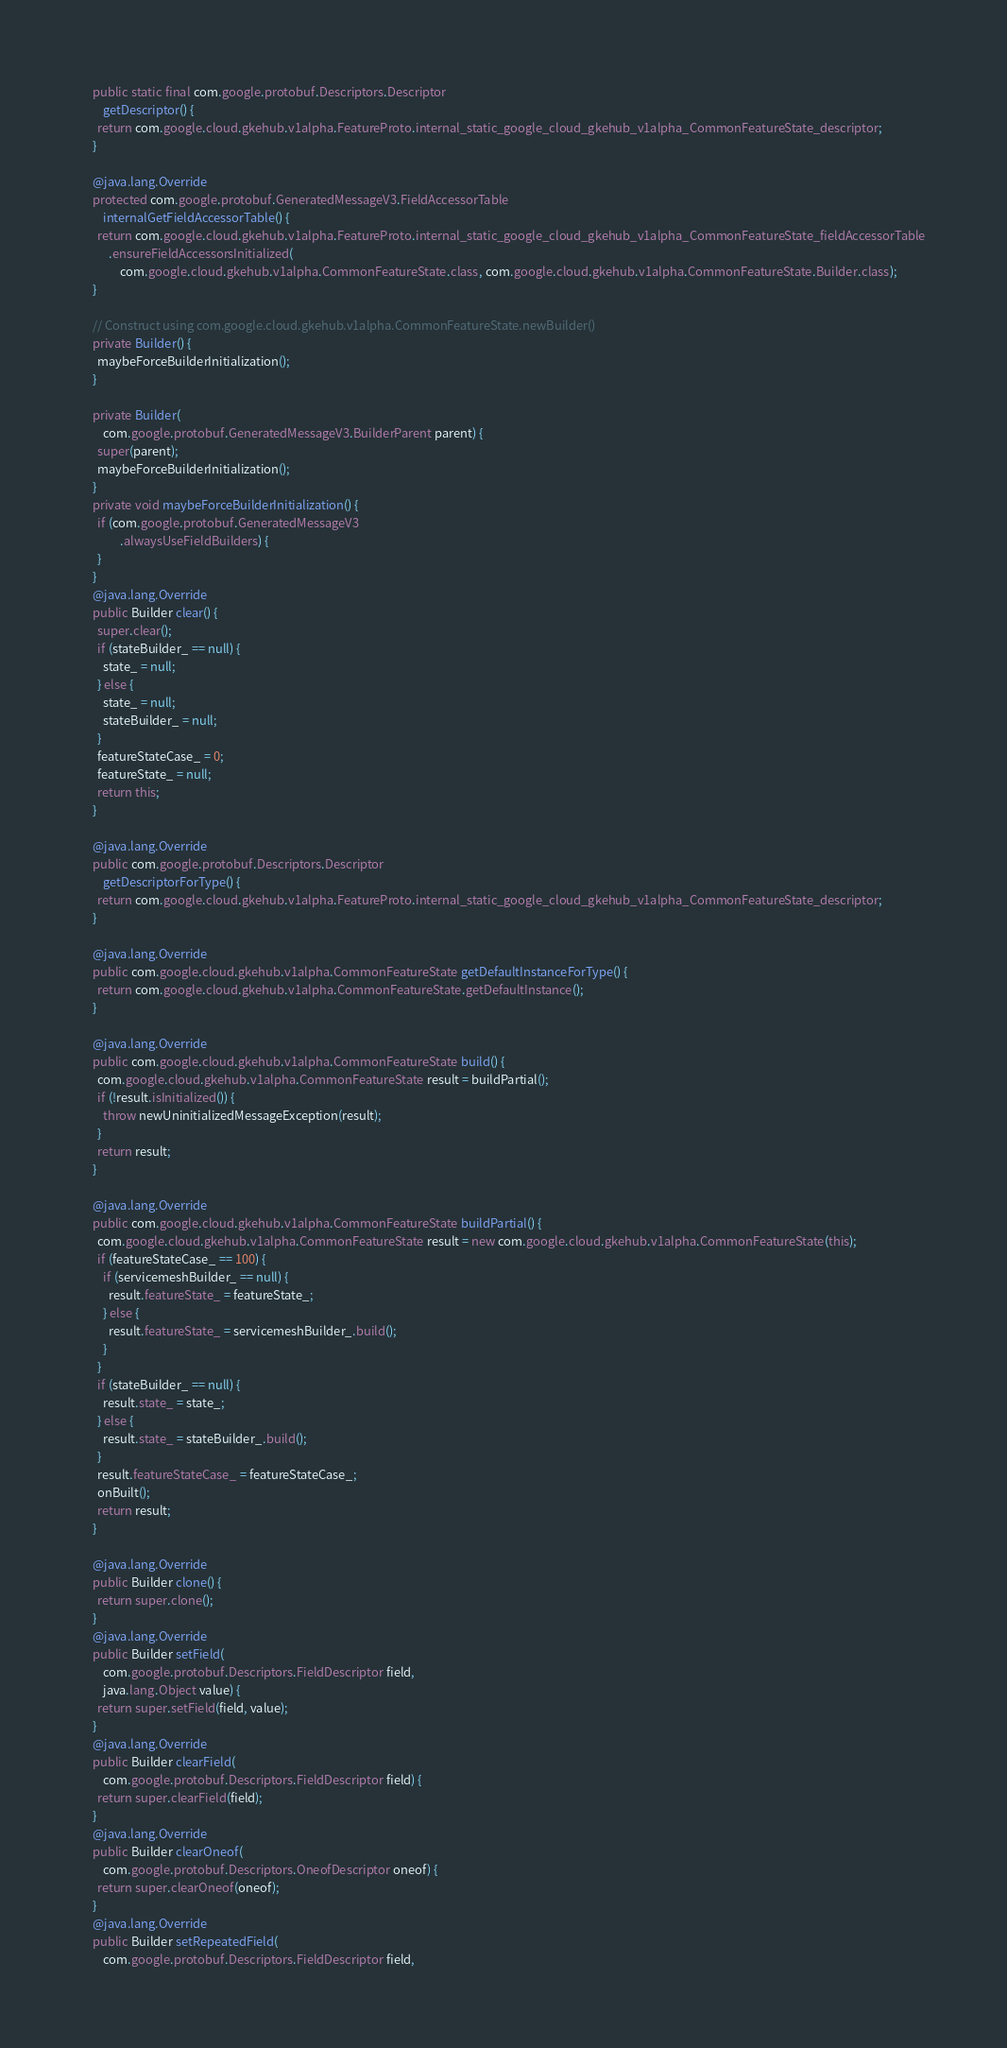Convert code to text. <code><loc_0><loc_0><loc_500><loc_500><_Java_>    public static final com.google.protobuf.Descriptors.Descriptor
        getDescriptor() {
      return com.google.cloud.gkehub.v1alpha.FeatureProto.internal_static_google_cloud_gkehub_v1alpha_CommonFeatureState_descriptor;
    }

    @java.lang.Override
    protected com.google.protobuf.GeneratedMessageV3.FieldAccessorTable
        internalGetFieldAccessorTable() {
      return com.google.cloud.gkehub.v1alpha.FeatureProto.internal_static_google_cloud_gkehub_v1alpha_CommonFeatureState_fieldAccessorTable
          .ensureFieldAccessorsInitialized(
              com.google.cloud.gkehub.v1alpha.CommonFeatureState.class, com.google.cloud.gkehub.v1alpha.CommonFeatureState.Builder.class);
    }

    // Construct using com.google.cloud.gkehub.v1alpha.CommonFeatureState.newBuilder()
    private Builder() {
      maybeForceBuilderInitialization();
    }

    private Builder(
        com.google.protobuf.GeneratedMessageV3.BuilderParent parent) {
      super(parent);
      maybeForceBuilderInitialization();
    }
    private void maybeForceBuilderInitialization() {
      if (com.google.protobuf.GeneratedMessageV3
              .alwaysUseFieldBuilders) {
      }
    }
    @java.lang.Override
    public Builder clear() {
      super.clear();
      if (stateBuilder_ == null) {
        state_ = null;
      } else {
        state_ = null;
        stateBuilder_ = null;
      }
      featureStateCase_ = 0;
      featureState_ = null;
      return this;
    }

    @java.lang.Override
    public com.google.protobuf.Descriptors.Descriptor
        getDescriptorForType() {
      return com.google.cloud.gkehub.v1alpha.FeatureProto.internal_static_google_cloud_gkehub_v1alpha_CommonFeatureState_descriptor;
    }

    @java.lang.Override
    public com.google.cloud.gkehub.v1alpha.CommonFeatureState getDefaultInstanceForType() {
      return com.google.cloud.gkehub.v1alpha.CommonFeatureState.getDefaultInstance();
    }

    @java.lang.Override
    public com.google.cloud.gkehub.v1alpha.CommonFeatureState build() {
      com.google.cloud.gkehub.v1alpha.CommonFeatureState result = buildPartial();
      if (!result.isInitialized()) {
        throw newUninitializedMessageException(result);
      }
      return result;
    }

    @java.lang.Override
    public com.google.cloud.gkehub.v1alpha.CommonFeatureState buildPartial() {
      com.google.cloud.gkehub.v1alpha.CommonFeatureState result = new com.google.cloud.gkehub.v1alpha.CommonFeatureState(this);
      if (featureStateCase_ == 100) {
        if (servicemeshBuilder_ == null) {
          result.featureState_ = featureState_;
        } else {
          result.featureState_ = servicemeshBuilder_.build();
        }
      }
      if (stateBuilder_ == null) {
        result.state_ = state_;
      } else {
        result.state_ = stateBuilder_.build();
      }
      result.featureStateCase_ = featureStateCase_;
      onBuilt();
      return result;
    }

    @java.lang.Override
    public Builder clone() {
      return super.clone();
    }
    @java.lang.Override
    public Builder setField(
        com.google.protobuf.Descriptors.FieldDescriptor field,
        java.lang.Object value) {
      return super.setField(field, value);
    }
    @java.lang.Override
    public Builder clearField(
        com.google.protobuf.Descriptors.FieldDescriptor field) {
      return super.clearField(field);
    }
    @java.lang.Override
    public Builder clearOneof(
        com.google.protobuf.Descriptors.OneofDescriptor oneof) {
      return super.clearOneof(oneof);
    }
    @java.lang.Override
    public Builder setRepeatedField(
        com.google.protobuf.Descriptors.FieldDescriptor field,</code> 